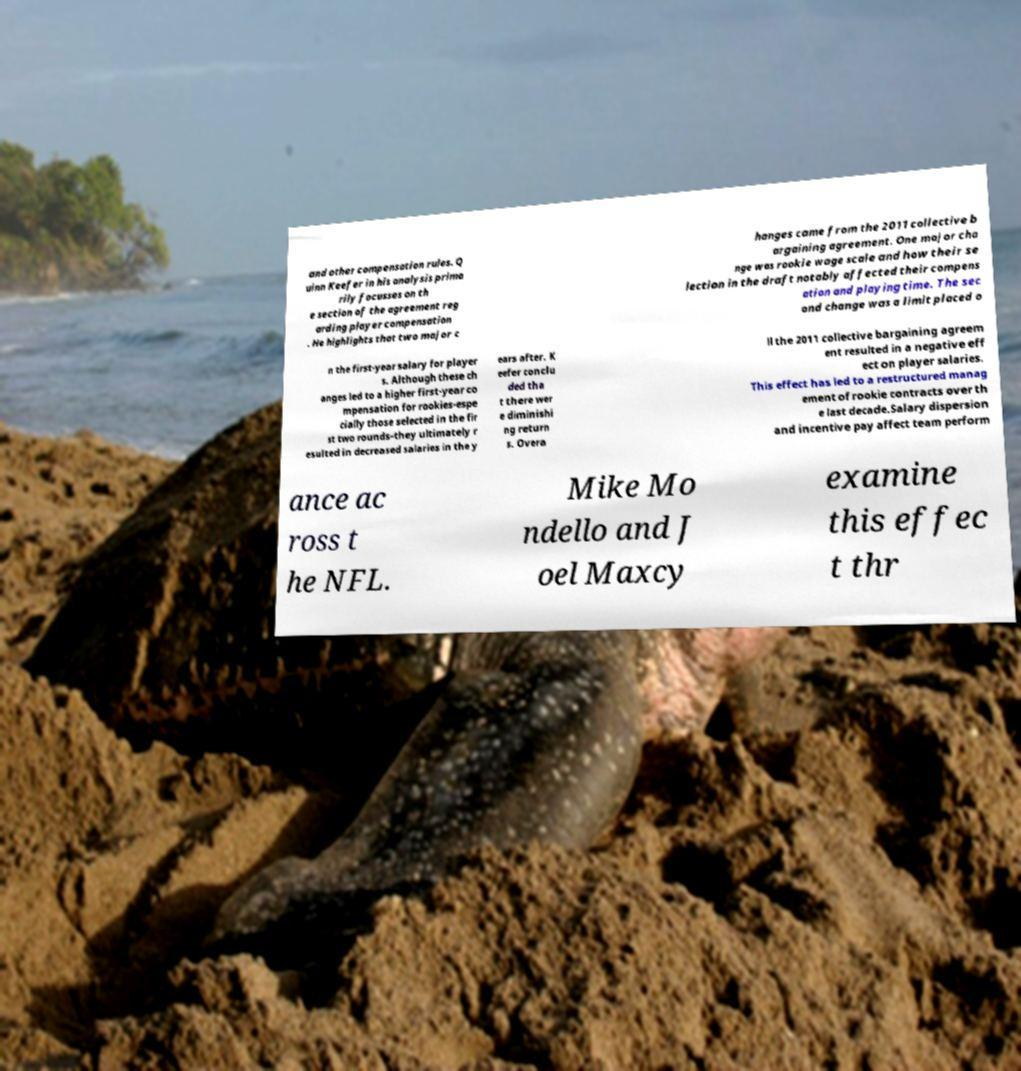Can you read and provide the text displayed in the image?This photo seems to have some interesting text. Can you extract and type it out for me? and other compensation rules. Q uinn Keefer in his analysis prima rily focusses on th e section of the agreement reg arding player compensation . He highlights that two major c hanges came from the 2011 collective b argaining agreement. One major cha nge was rookie wage scale and how their se lection in the draft notably affected their compens ation and playing time. The sec ond change was a limit placed o n the first-year salary for player s. Although these ch anges led to a higher first-year co mpensation for rookies-espe cially those selected in the fir st two rounds–they ultimately r esulted in decreased salaries in the y ears after. K eefer conclu ded tha t there wer e diminishi ng return s. Overa ll the 2011 collective bargaining agreem ent resulted in a negative eff ect on player salaries. This effect has led to a restructured manag ement of rookie contracts over th e last decade.Salary dispersion and incentive pay affect team perform ance ac ross t he NFL. Mike Mo ndello and J oel Maxcy examine this effec t thr 